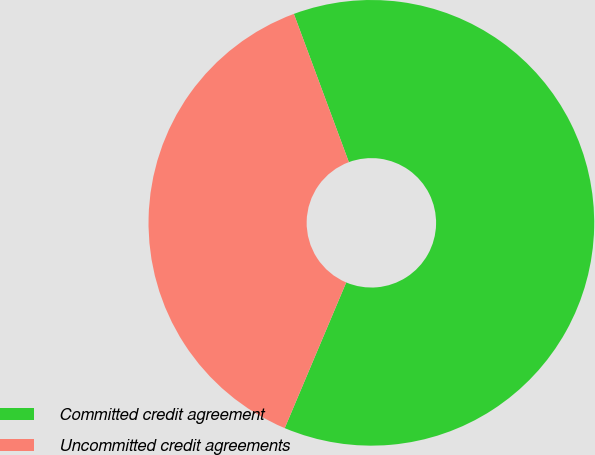<chart> <loc_0><loc_0><loc_500><loc_500><pie_chart><fcel>Committed credit agreement<fcel>Uncommitted credit agreements<nl><fcel>62.01%<fcel>37.99%<nl></chart> 